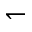Convert formula to latex. <formula><loc_0><loc_0><loc_500><loc_500>\leftharpoondown</formula> 